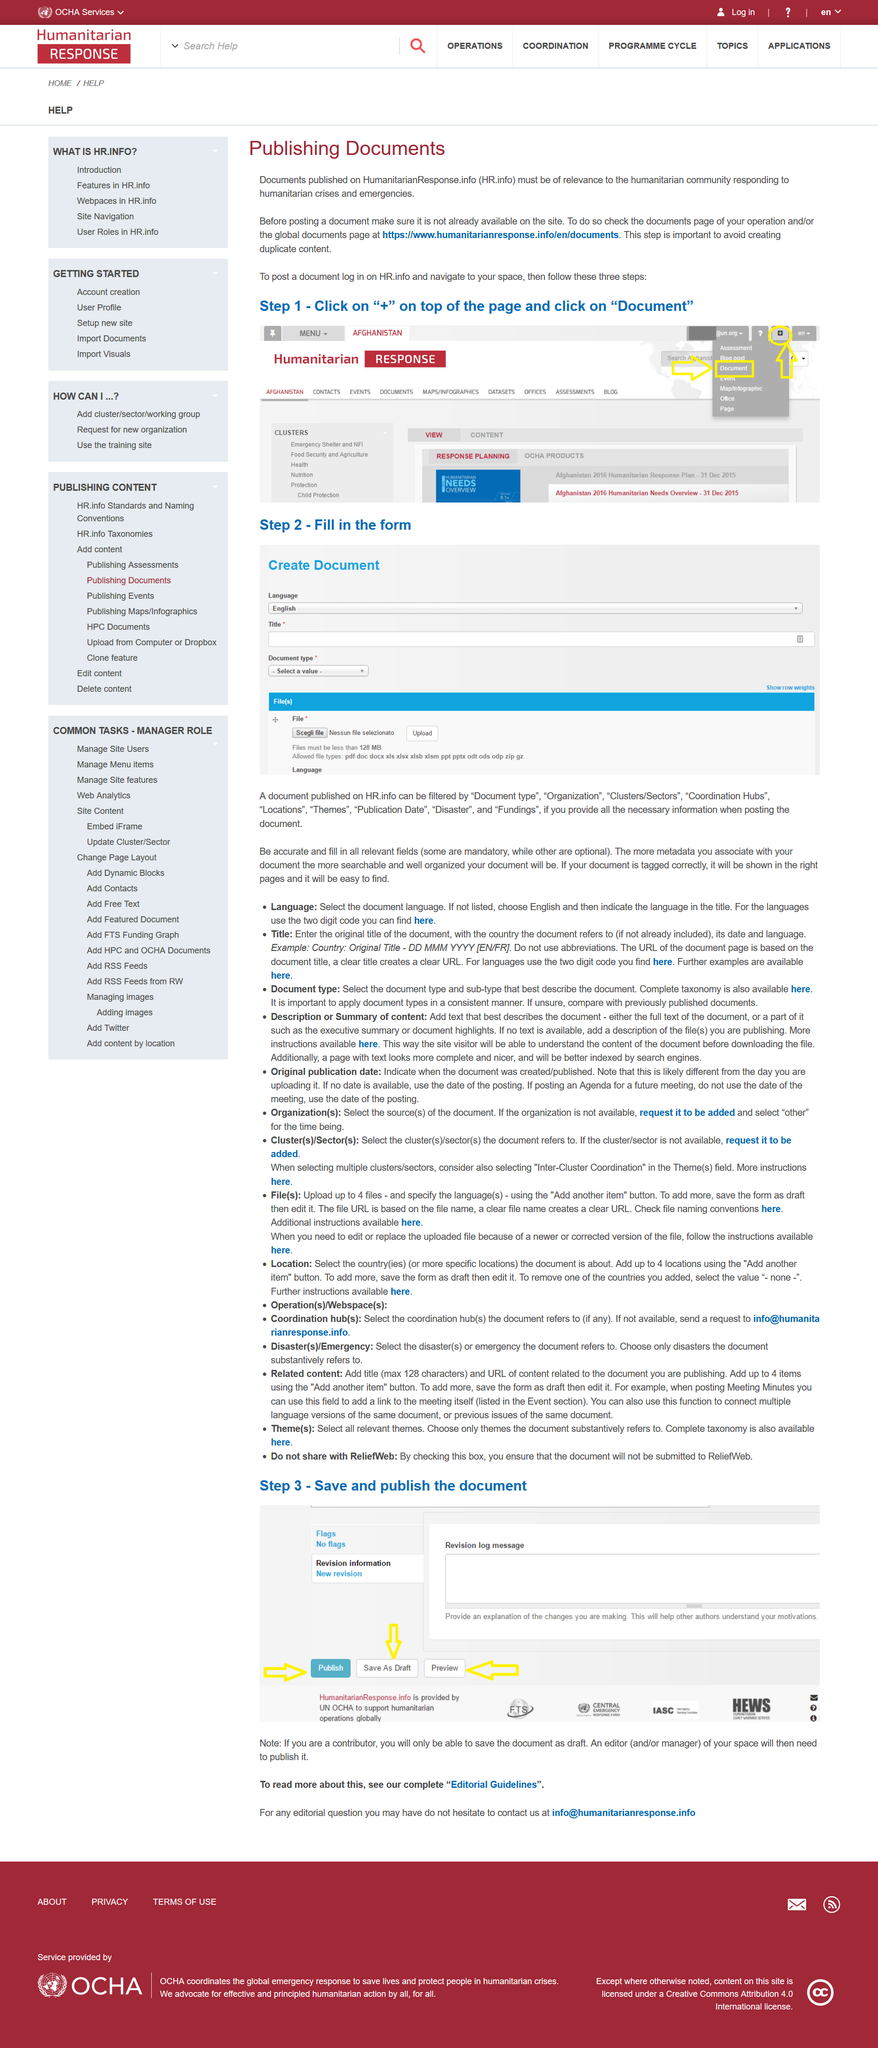Point out several critical features in this image. Step 2 involves filling in the form... All documents published on HR.info must be of relevance to the humanitarian community responding to humanitarian crises and emergencies, and must adhere to the highest standards of quality and accuracy. To post a document on HR.info, the first step is to click on the "+" button located at the top of the page and select "Document" from the drop-down menu. It is necessary to ensure that a document being posted on HR.info has not already been available on the site prior to posting. If a document is correctly tagged, it will be displayed in the appropriate pages. 